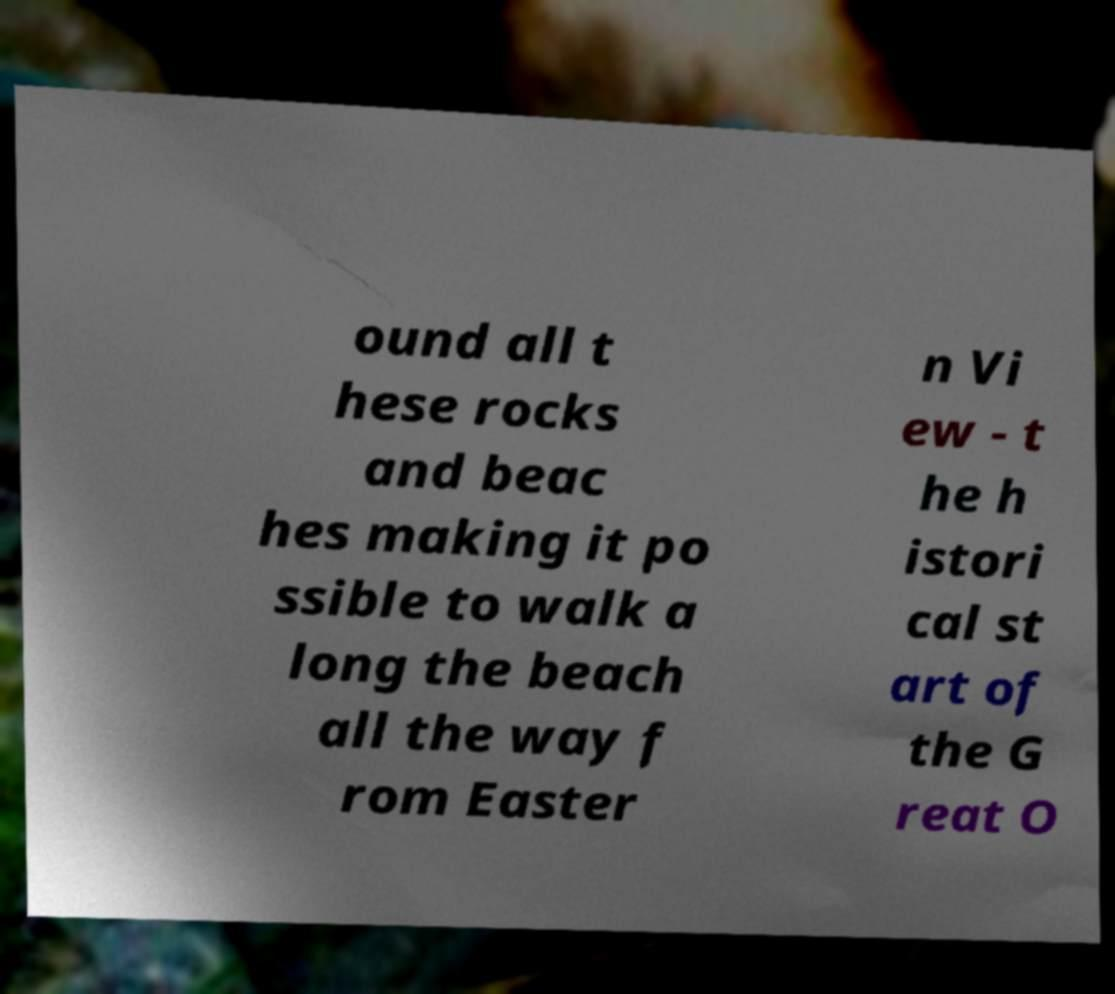Could you extract and type out the text from this image? ound all t hese rocks and beac hes making it po ssible to walk a long the beach all the way f rom Easter n Vi ew - t he h istori cal st art of the G reat O 